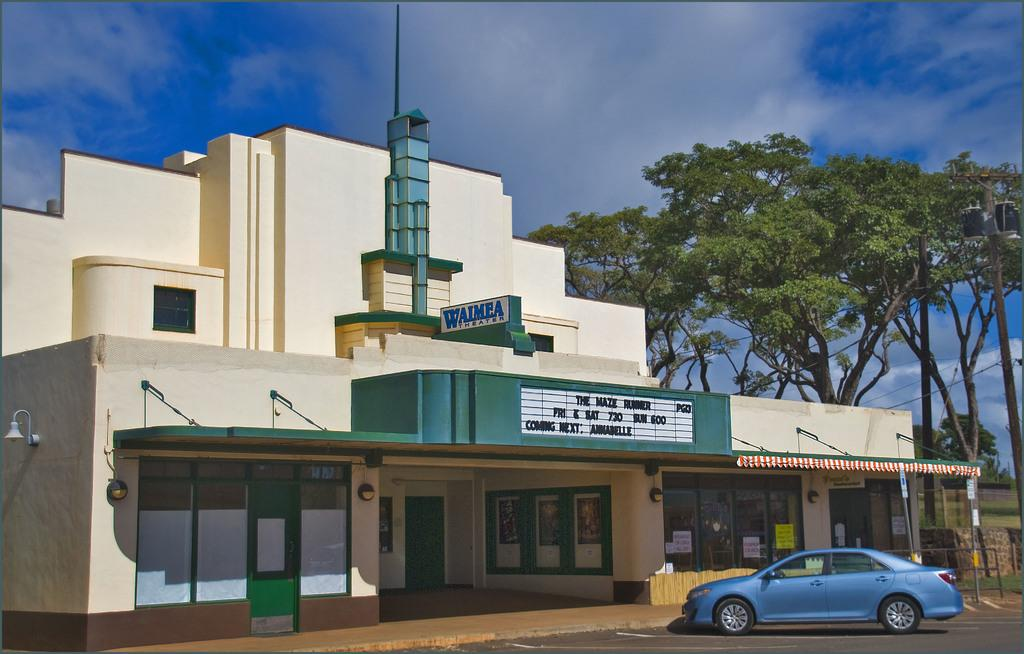What type of structure is visible in the image? There is a building in the image. What can be seen beside the building? Trees are present beside the building. What mode of transportation is parked in front of the building? There is a car in front of the building. What is visible in the background of the image? The sky is visible in the background of the image. How does the rock contribute to the building's tax in the image? There is no rock present in the image, and therefore it cannot contribute to the building's tax. 